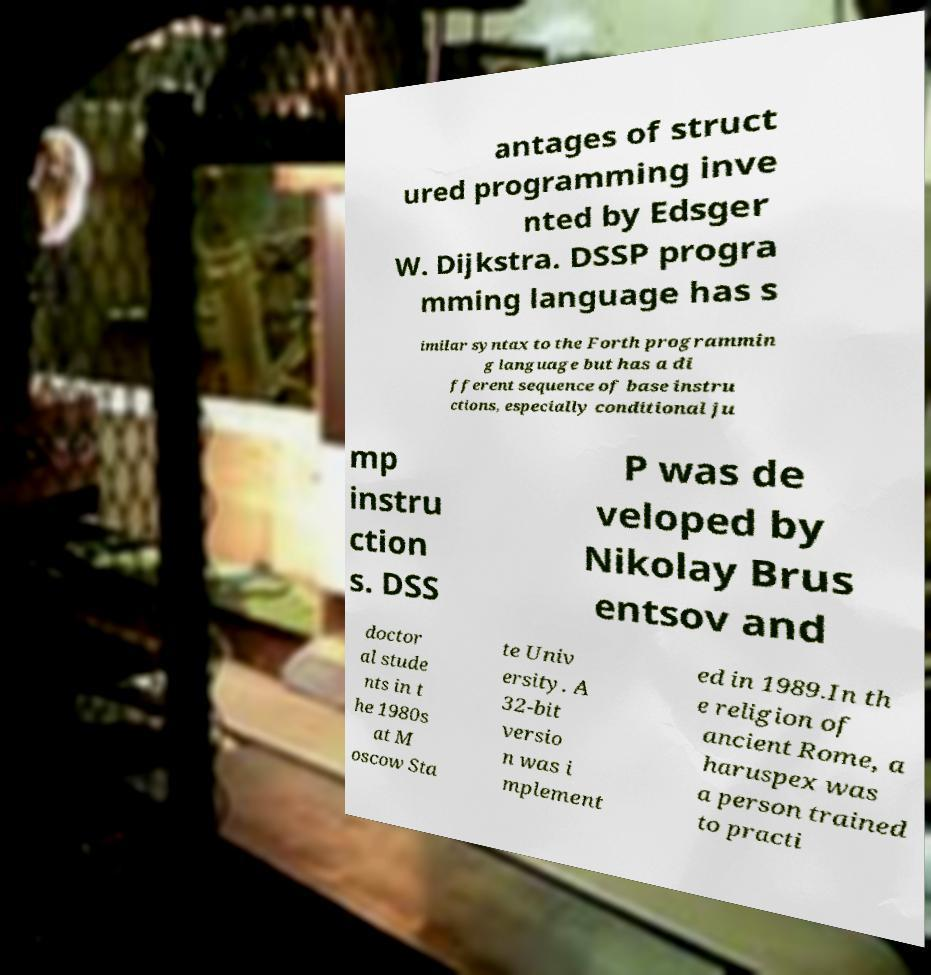I need the written content from this picture converted into text. Can you do that? antages of struct ured programming inve nted by Edsger W. Dijkstra. DSSP progra mming language has s imilar syntax to the Forth programmin g language but has a di fferent sequence of base instru ctions, especially conditional ju mp instru ction s. DSS P was de veloped by Nikolay Brus entsov and doctor al stude nts in t he 1980s at M oscow Sta te Univ ersity. A 32-bit versio n was i mplement ed in 1989.In th e religion of ancient Rome, a haruspex was a person trained to practi 